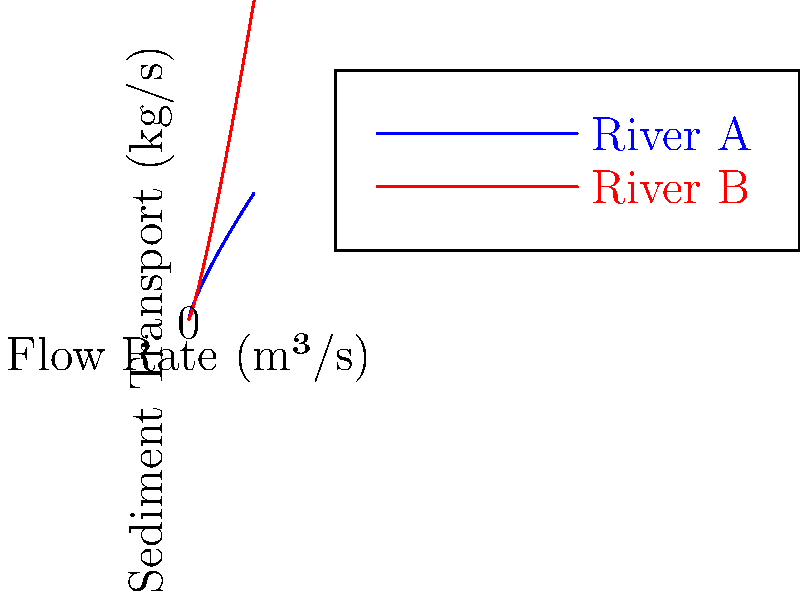The graph shows the relationship between flow rate and sediment transport for two river systems in the Amazon. River A (blue curve) represents a more established, slower-moving river, while River B (red curve) represents a faster, more erosive river. At what flow rate (in m³/s) do both rivers transport the same amount of sediment? To solve this problem, we need to find the point where the two curves intersect. This can be done mathematically by setting the equations for both curves equal to each other:

1) River A equation: $y = 0.5x^{0.8}$
2) River B equation: $y = 0.2x^{1.2}$

3) At the intersection point: $0.5x^{0.8} = 0.2x^{1.2}$

4) Simplify: $2.5 = x^{0.4}$

5) Raise both sides to the power of 2.5:
   $(2.5)^{2.5} = x^{1}$

6) Calculate: $9.882 = x$

Therefore, the flow rate at which both rivers transport the same amount of sediment is approximately 9.882 m³/s.

This intersection point is significant for environmental conservation efforts as it represents a critical flow rate where the sediment transport dynamics of the two river systems align, potentially affecting erosion patterns, habitat formation, and nutrient distribution in the Amazon ecosystem.
Answer: 9.882 m³/s 